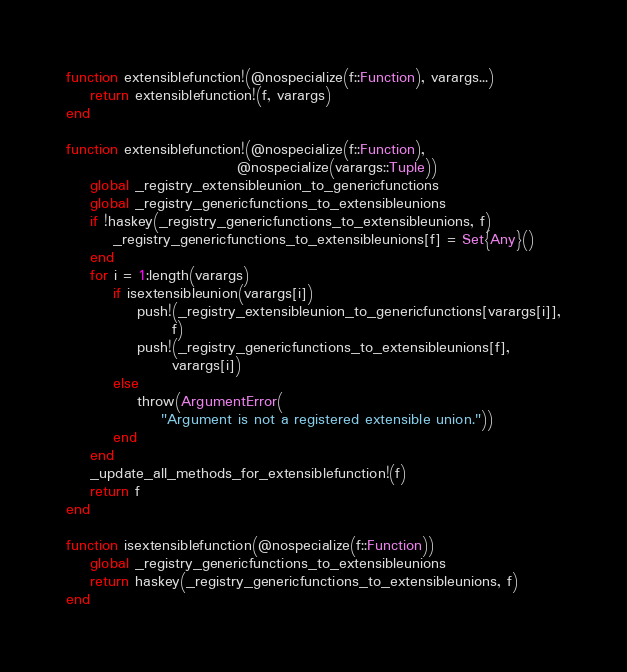<code> <loc_0><loc_0><loc_500><loc_500><_Julia_>function extensiblefunction!(@nospecialize(f::Function), varargs...)
    return extensiblefunction!(f, varargs)
end

function extensiblefunction!(@nospecialize(f::Function),
                             @nospecialize(varargs::Tuple))
    global _registry_extensibleunion_to_genericfunctions
    global _registry_genericfunctions_to_extensibleunions
    if !haskey(_registry_genericfunctions_to_extensibleunions, f)
        _registry_genericfunctions_to_extensibleunions[f] = Set{Any}()
    end
    for i = 1:length(varargs)
        if isextensibleunion(varargs[i])
            push!(_registry_extensibleunion_to_genericfunctions[varargs[i]],
                  f)
            push!(_registry_genericfunctions_to_extensibleunions[f],
                  varargs[i])
        else
            throw(ArgumentError(
                "Argument is not a registered extensible union."))
        end
    end
    _update_all_methods_for_extensiblefunction!(f)
    return f
end

function isextensiblefunction(@nospecialize(f::Function))
    global _registry_genericfunctions_to_extensibleunions
    return haskey(_registry_genericfunctions_to_extensibleunions, f)
end
</code> 